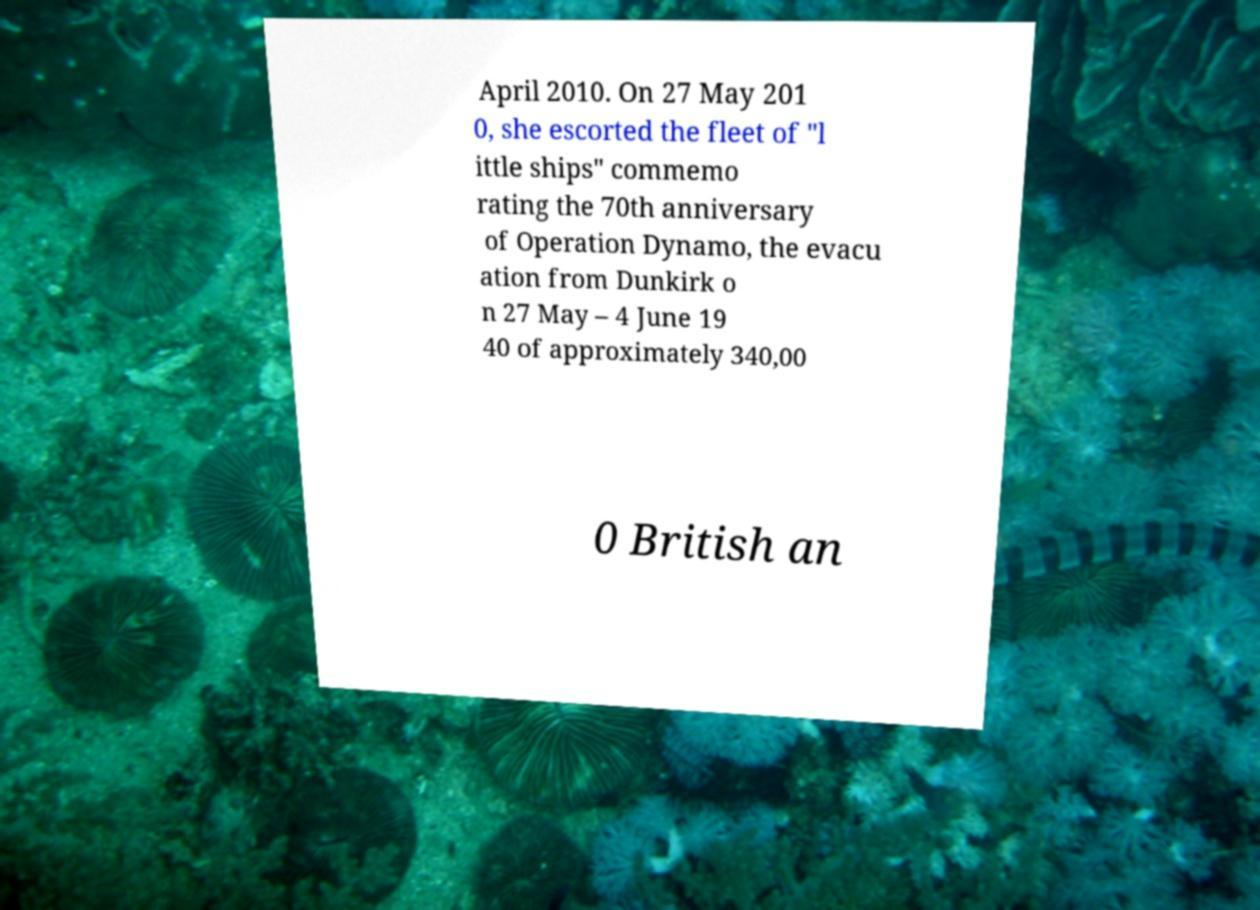What messages or text are displayed in this image? I need them in a readable, typed format. April 2010. On 27 May 201 0, she escorted the fleet of "l ittle ships" commemo rating the 70th anniversary of Operation Dynamo, the evacu ation from Dunkirk o n 27 May – 4 June 19 40 of approximately 340,00 0 British an 